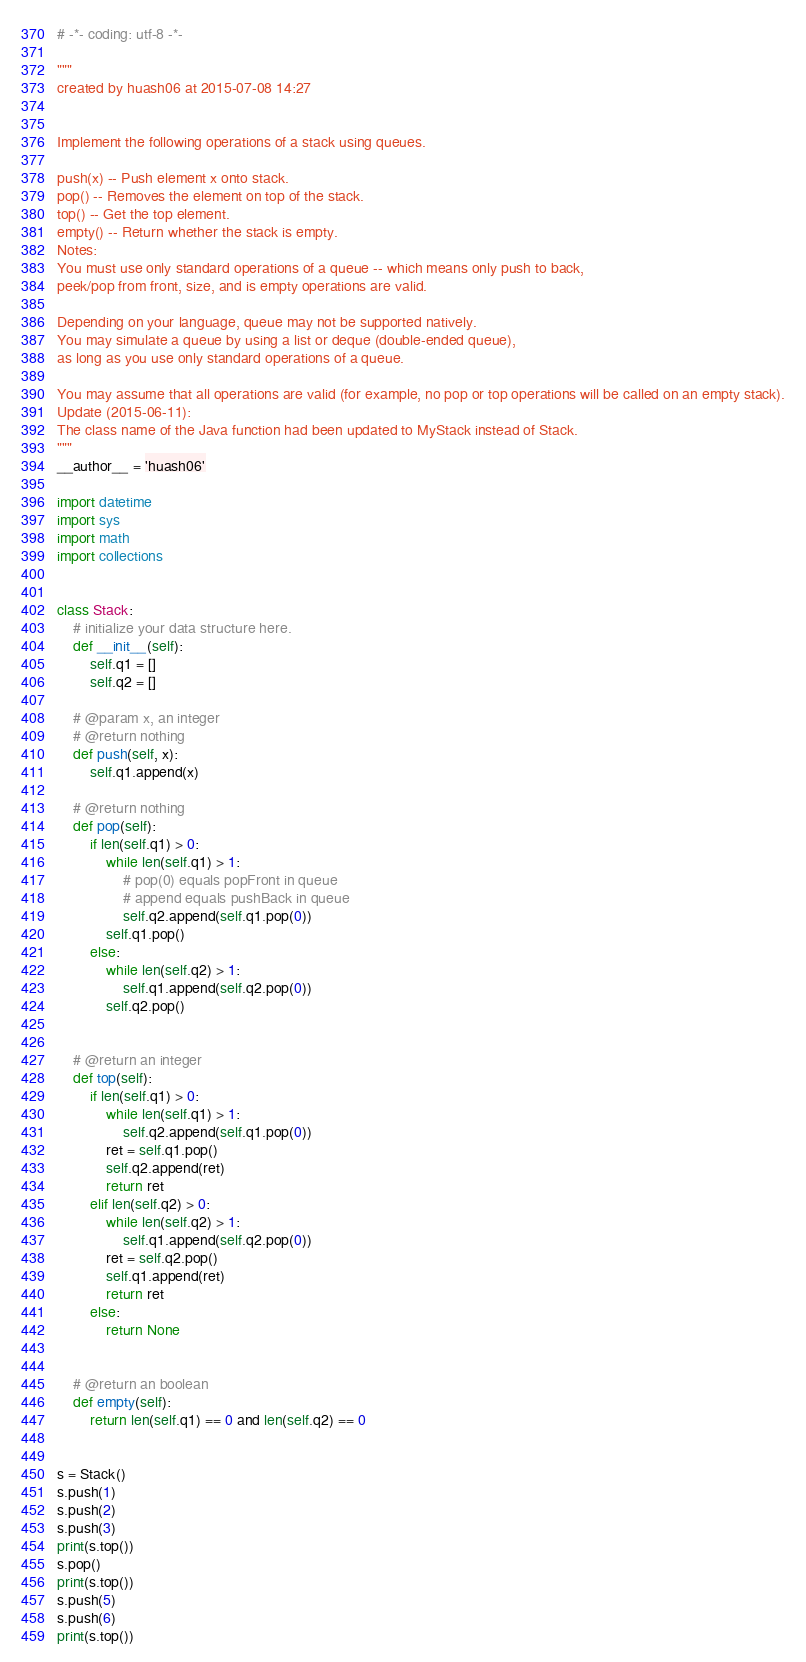Convert code to text. <code><loc_0><loc_0><loc_500><loc_500><_Python_># -*- coding: utf-8 -*-

"""
created by huash06 at 2015-07-08 14:27


Implement the following operations of a stack using queues.

push(x) -- Push element x onto stack.
pop() -- Removes the element on top of the stack.
top() -- Get the top element.
empty() -- Return whether the stack is empty.
Notes:
You must use only standard operations of a queue -- which means only push to back,
peek/pop from front, size, and is empty operations are valid.

Depending on your language, queue may not be supported natively.
You may simulate a queue by using a list or deque (double-ended queue),
as long as you use only standard operations of a queue.

You may assume that all operations are valid (for example, no pop or top operations will be called on an empty stack).
Update (2015-06-11):
The class name of the Java function had been updated to MyStack instead of Stack.
"""
__author__ = 'huash06'

import datetime
import sys
import math
import collections


class Stack:
    # initialize your data structure here.
    def __init__(self):
        self.q1 = []
        self.q2 = []

    # @param x, an integer
    # @return nothing
    def push(self, x):
        self.q1.append(x)

    # @return nothing
    def pop(self):
        if len(self.q1) > 0:
            while len(self.q1) > 1:
                # pop(0) equals popFront in queue
                # append equals pushBack in queue
                self.q2.append(self.q1.pop(0))
            self.q1.pop()
        else:
            while len(self.q2) > 1:
                self.q1.append(self.q2.pop(0))
            self.q2.pop()


    # @return an integer
    def top(self):
        if len(self.q1) > 0:
            while len(self.q1) > 1:
                self.q2.append(self.q1.pop(0))
            ret = self.q1.pop()
            self.q2.append(ret)
            return ret
        elif len(self.q2) > 0:
            while len(self.q2) > 1:
                self.q1.append(self.q2.pop(0))
            ret = self.q2.pop()
            self.q1.append(ret)
            return ret
        else:
            return None


    # @return an boolean
    def empty(self):
        return len(self.q1) == 0 and len(self.q2) == 0


s = Stack()
s.push(1)
s.push(2)
s.push(3)
print(s.top())
s.pop()
print(s.top())
s.push(5)
s.push(6)
print(s.top())</code> 